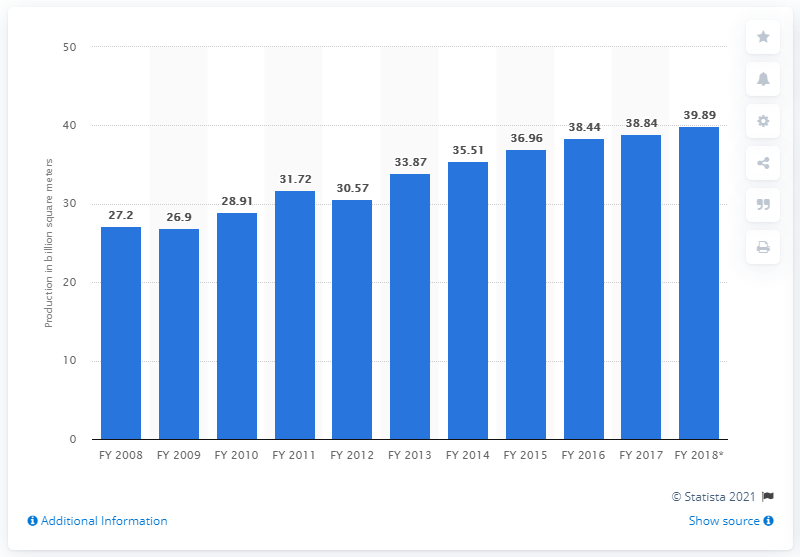Outline some significant characteristics in this image. India's cotton production increased by 38.84% in the fiscal year 2014, according to the data. India produced 38.84 million meters of cotton fabric by the end of the fiscal year 2017. 